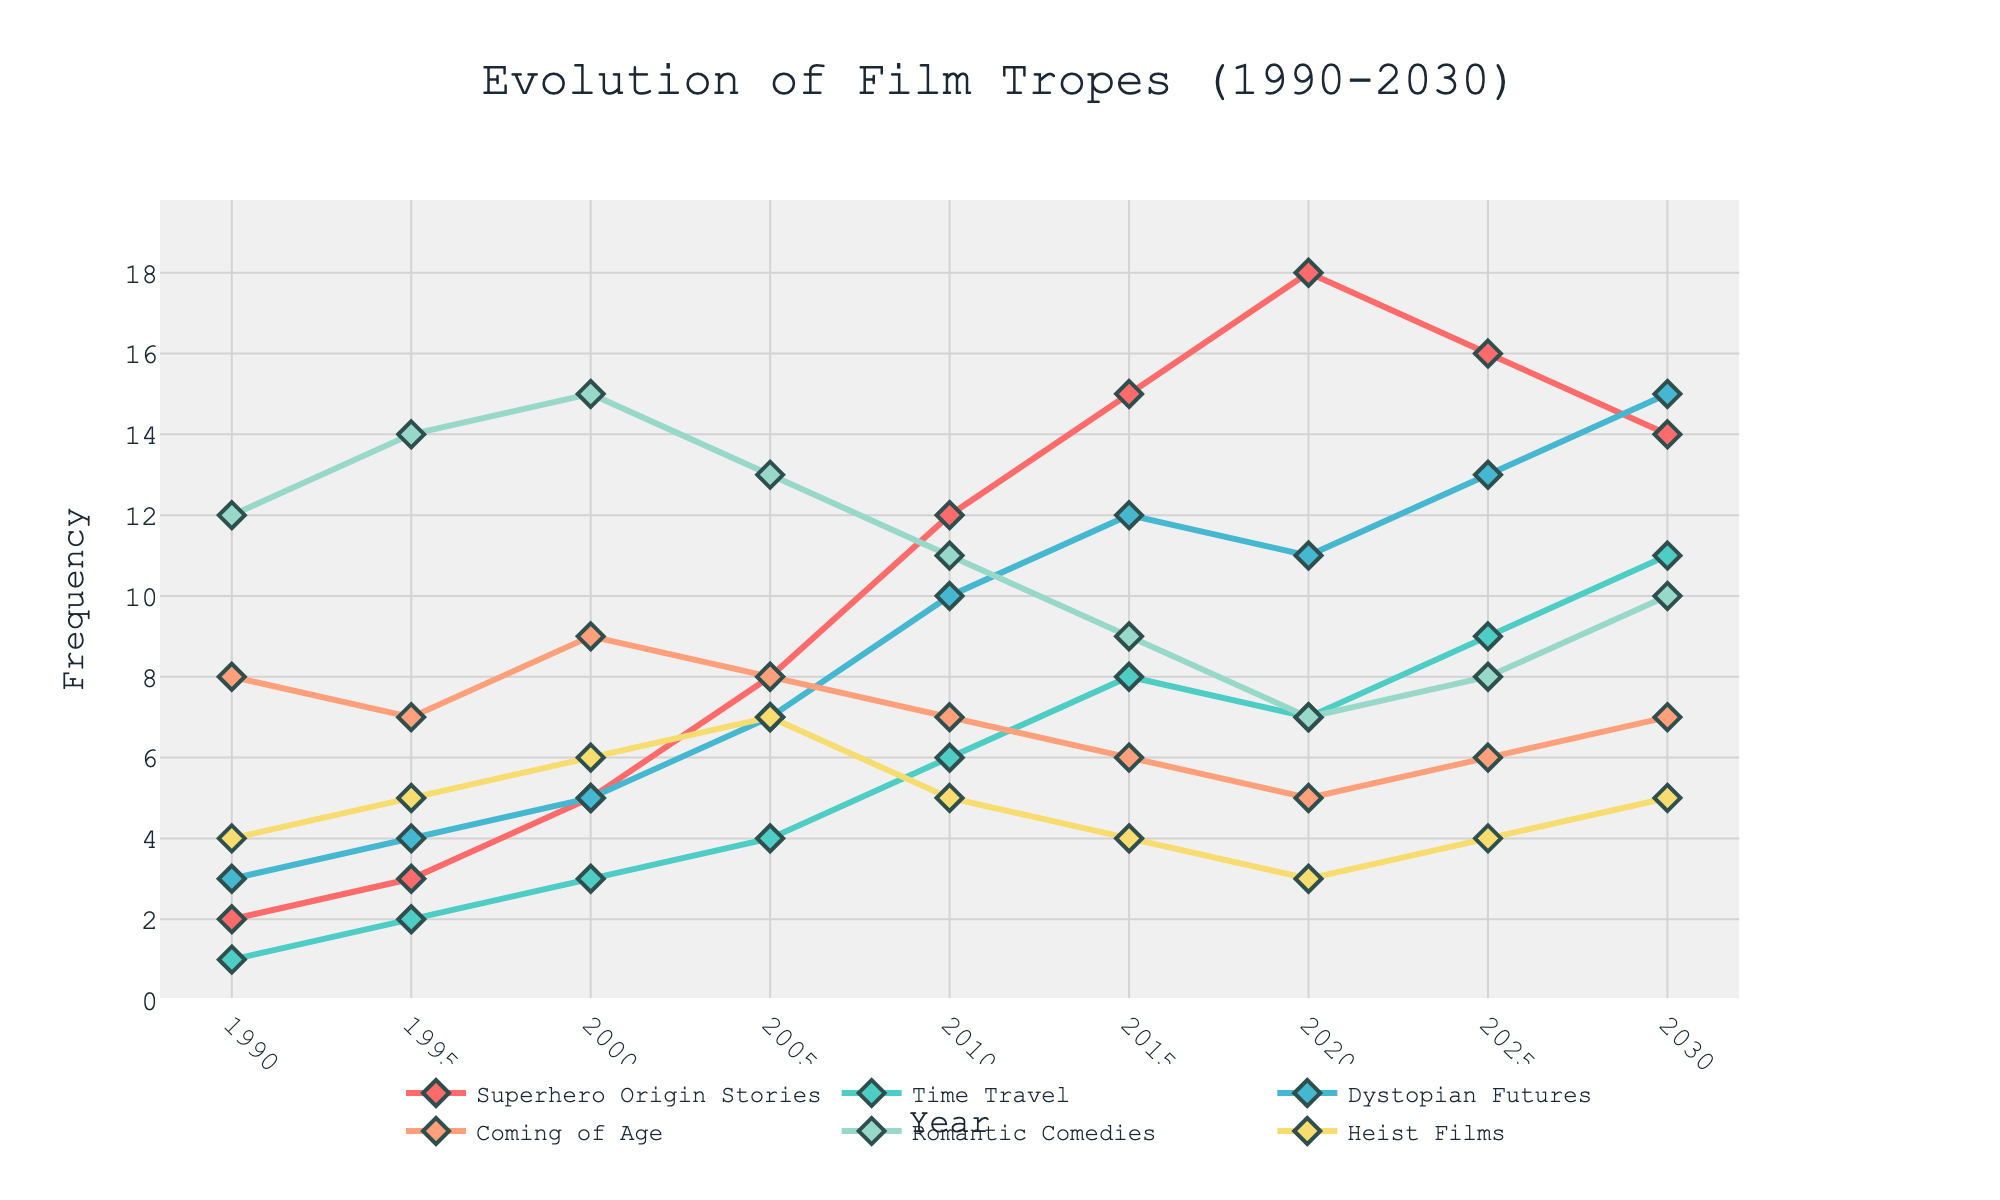What's the trend in the frequency of Superhero Origin Stories over the last three decades? From 1990 to 2030, the frequency of Superhero Origin Stories shows a gradual increase, peaking in 2020 and then slightly declining by 2030. Initially, it starts with a low of 2 in 1990 and reaches a high of 18 in 2020 before dropping to 14 in 2030.
Answer: Increasing trend with a peak in 2020 Between 2010 and 2020, which trope experienced the greatest increase in frequency? To determine the trope with the greatest increase, we need to find the difference in frequency for each trope between 2010 and 2020: Superhero Origin Stories (18-12=6), Time Travel (7-6=1), Dystopian Futures (11-10=1), Coming of Age (5-7=-2), Romantic Comedies (7-11=-4), Heist Films (3-5=-2). Superhero Origin Stories has the largest increase of 6.
Answer: Superhero Origin Stories How did the frequency of Romantic Comedies change from 1990 to 2030? In 1990, the frequency of Romantic Comedies was 12. It increased over time, peaking at 15 in 2000. After that, it showed a general decline to 10 by 2030. Therefore, the pattern shows an initial increase followed by a decrease.
Answer: Peaked in 2000, then decreased What is the difference in frequency of Dystopian Futures between 1995 and 2030? In 1995, the frequency of Dystopian Futures was 4. By 2030, it increased to 15. Therefore, the difference is 15 - 4 = 11.
Answer: 11 Which trope had the highest frequency in 2000? The frequencies in 2000 are: Superhero Origin Stories (5), Time Travel (3), Dystopian Futures (5), Coming of Age (9), Romantic Comedies (15), Heist Films (6). Romantic Comedies had the highest frequency of 15.
Answer: Romantic Comedies What is the average frequency of the Heist Films from 1990 to 2030? The frequencies of Heist Films are 4, 5, 6, 7, 5, 4, 3, 4, 5 across the years. Sum these up: 4 + 5 + 6 + 7 + 5 + 4 + 3 + 4 + 5 = 43. There are 9 years, so the average is 43 / 9 ≈ 4.78.
Answer: 4.78 Compare the trend of Coming of Age films to Time Travel films between 2000 and 2025. Coming of Age films had a frequency of 9 in 2000, decreasing to 6 in 2025. Time Travel films increased from 3 in 2000 to 9 in 2025. Therefore, while Coming of Age films experienced a decline, Time Travel films increased.
Answer: Coming of Age decreased, Time Travel increased What is the combined frequency of Superhero Origin Stories and Time Travel films in 2025? The frequency of Superhero Origin Stories in 2025 is 16 and that of Time Travel films is 9. Combined, it's 16 + 9 = 25.
Answer: 25 By how much did the frequency of Dystopian Futures change from 2015 to 2030? In 2015, the frequency of Dystopian Futures was 12. By 2030, it increased to 15. Thus, the change is 15 - 12 = 3.
Answer: 3 